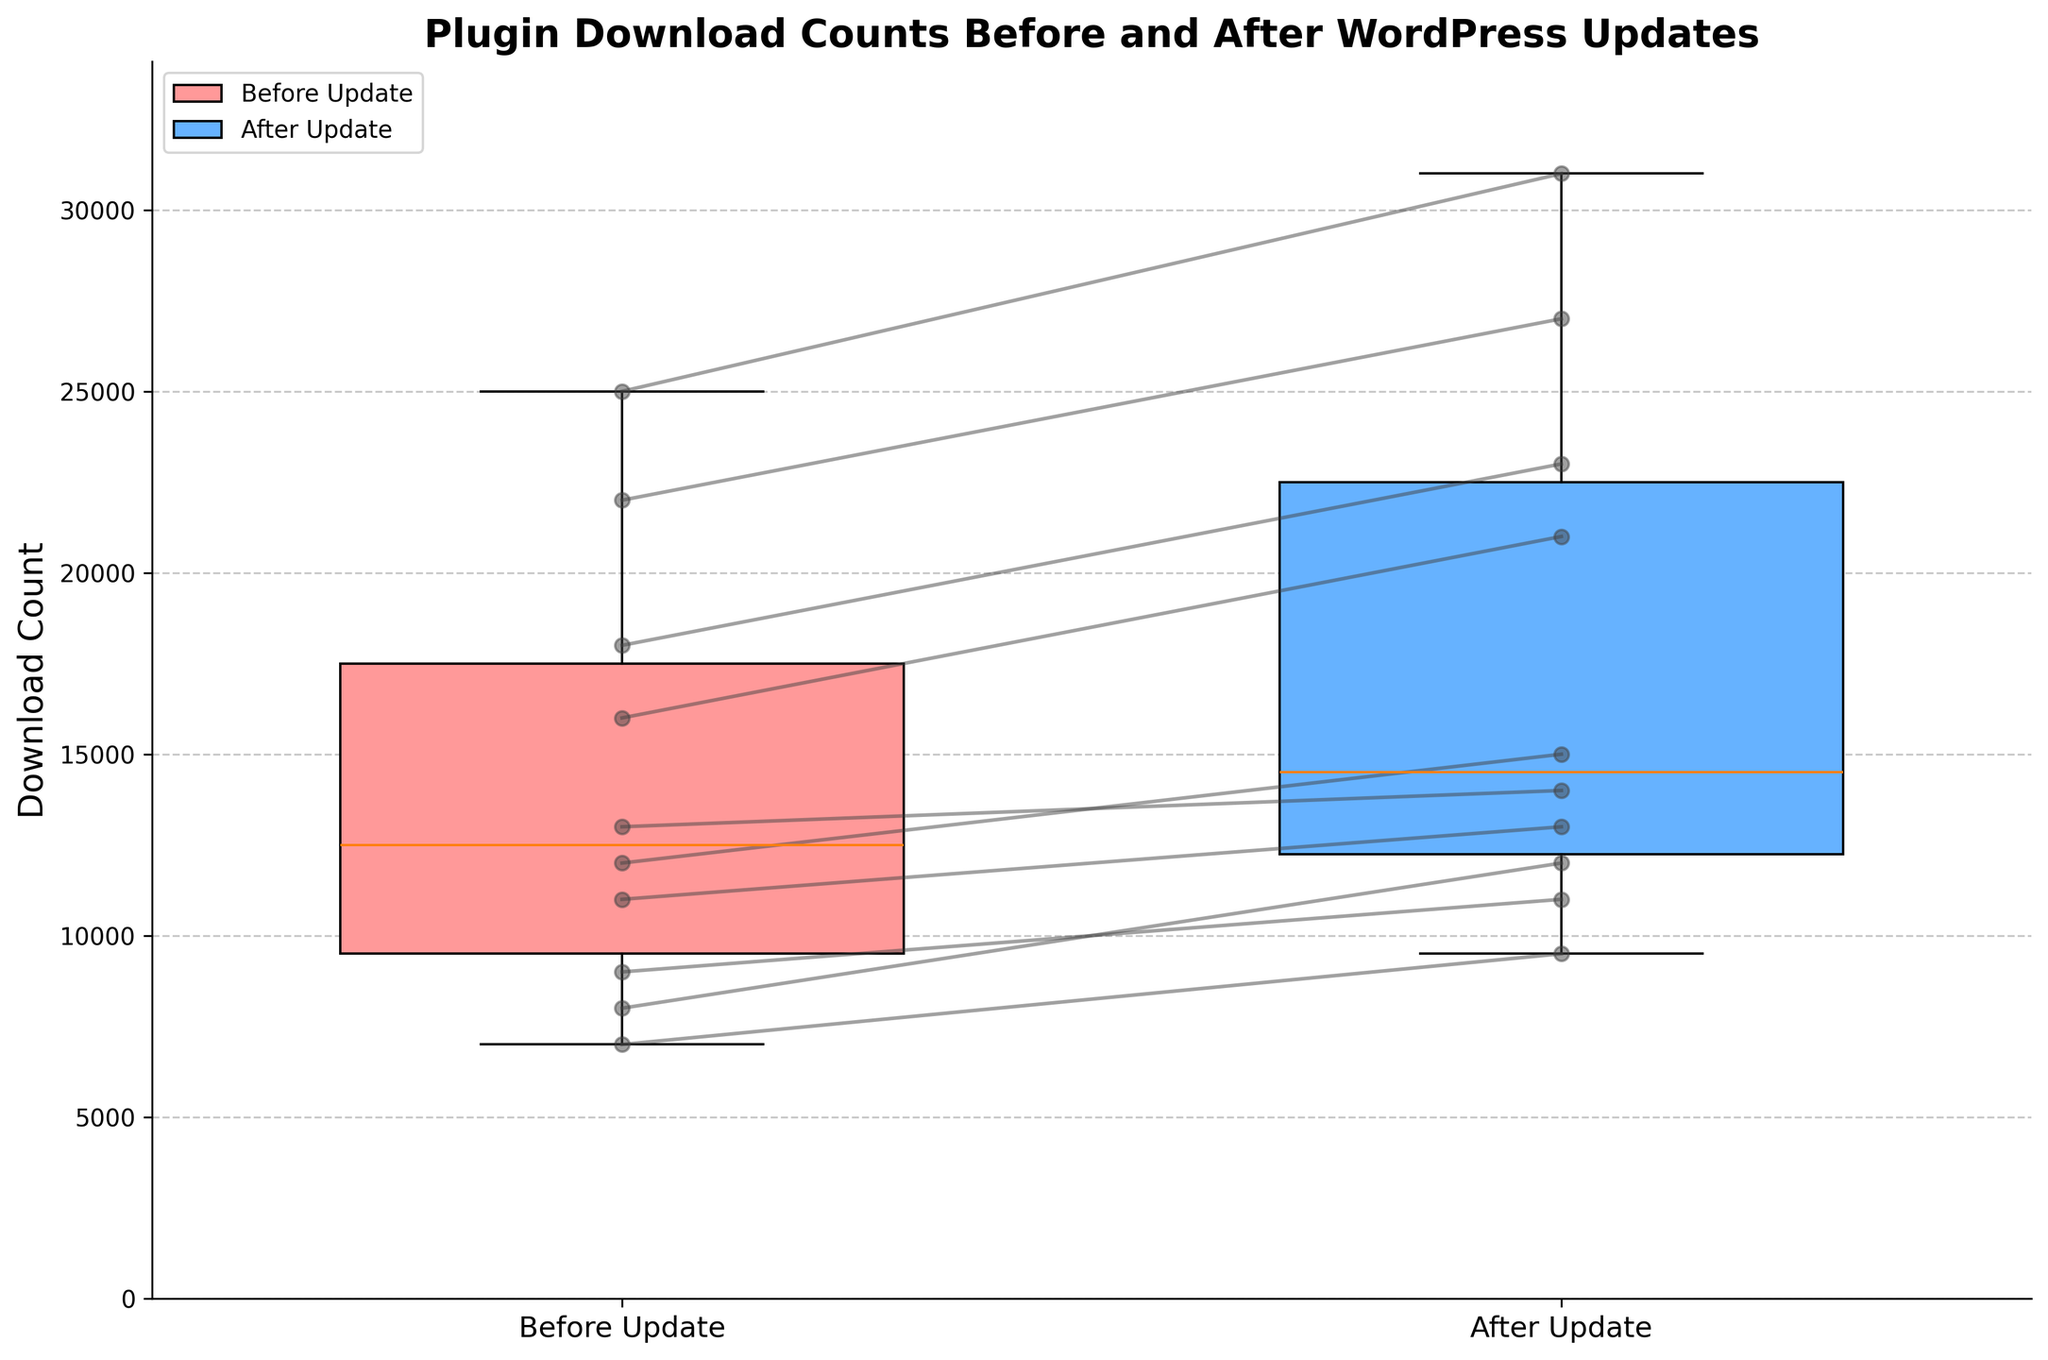How many groups are depicted in the box plot? The box plot shows two distinct groups labeled on the x-axis: 'Before Update' and 'After Update'. Each box plot represents one group.
Answer: Two What is the title of the figure? The title of the figure is displayed at the top of the plot, providing an overview of what the plot is about. The title reads "Plugin Download Counts Before and After WordPress Updates".
Answer: Plugin Download Counts Before and After WordPress Updates What do the colors of the boxes represent? The box plots are colored differently to represent different groups. The box colored in red represents 'Before Update', and the box colored in blue represents 'After Update'. This can be inferred from the legend located at the upper left of the plot.
Answer: 'Before Update' and 'After Update' Which group has a higher median download count? To determine the higher median download count, compare the median lines (horizontal lines inside the boxes) of the two groups. The median line for 'After Update' appears higher than the 'Before Update' group.
Answer: After Update What is the maximum download count for the 'Before Update' group? To find the maximum download count for the 'Before Update' group, look at the top whisker or any outliers above the box plot. The highest point on the 'Before Update' box plot represents the maximum download count.
Answer: 25000 Are there any outliers in either of the groups? Outliers are typically represented by individual data points plotted beyond the whiskers of the box plot. Inspect the plot for any such points outside the whiskers in either group.
Answer: No What is the interquartile range (IQR) for the 'After Update' group? The IQR is the range between the first quartile (bottom of the box) and the third quartile (top of the box). Estimate the values at these points for the 'After Update' group and subtract the first quartile from the third quartile.
Answer: 5600 Which group shows more variability in download counts? More variability is indicated by the length of the box and the whiskers. The 'After Update' group has a longer box and whiskers, suggesting higher variability compared to the 'Before Update' group.
Answer: After Update How many data points showed an increase in download counts after the update? Each data point is connected by a line between the 'Before Update' and 'After Update' groups. Count the number of lines that slope upwards.
Answer: 10 What is the average download count increase after the update? To find the average increase, subtract each 'Before Update' value from its corresponding 'After Update' value, sum these differences, and divide by the number of data points. Calculation steps:
  (15000-12000) + (11000-9000) + (31000-25000) + (23000-18000) + (14000-13000) + (9500-7000) + (21000-16000) + (27000-22000) + (12000-8000) + (13000-11000) = 36000
  36000 / 10 = 3600
Answer: 3600 